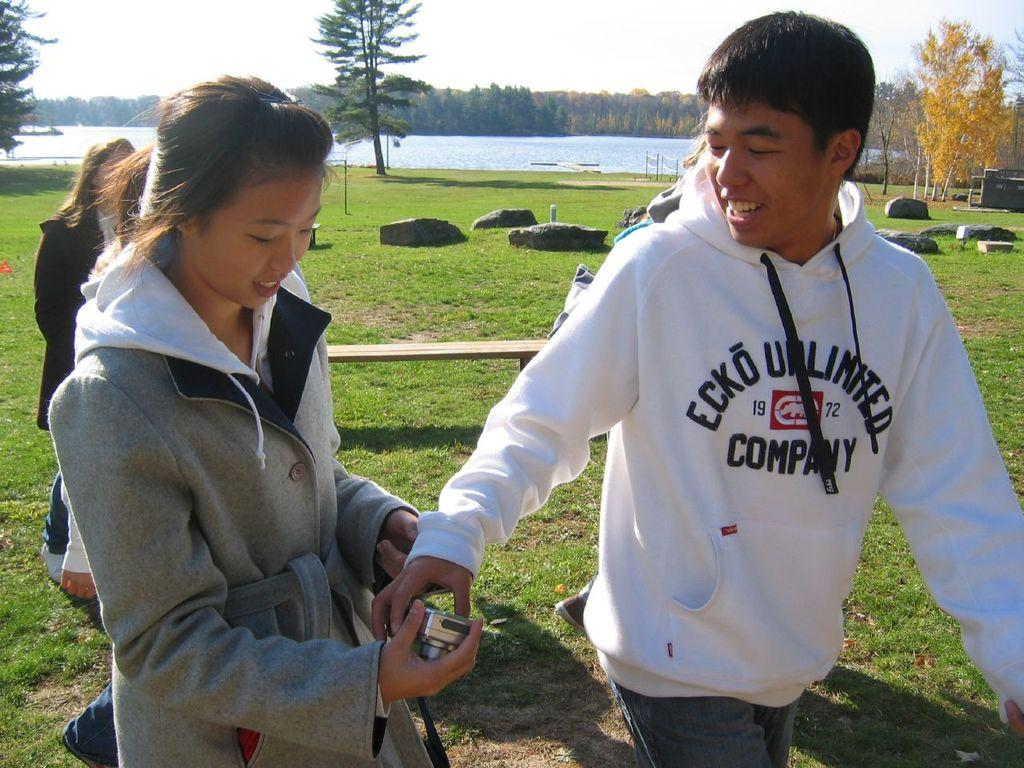Provide a one-sentence caption for the provided image. A man wearing an Ecko sweatshirt walks next to a woman holding a camera. 